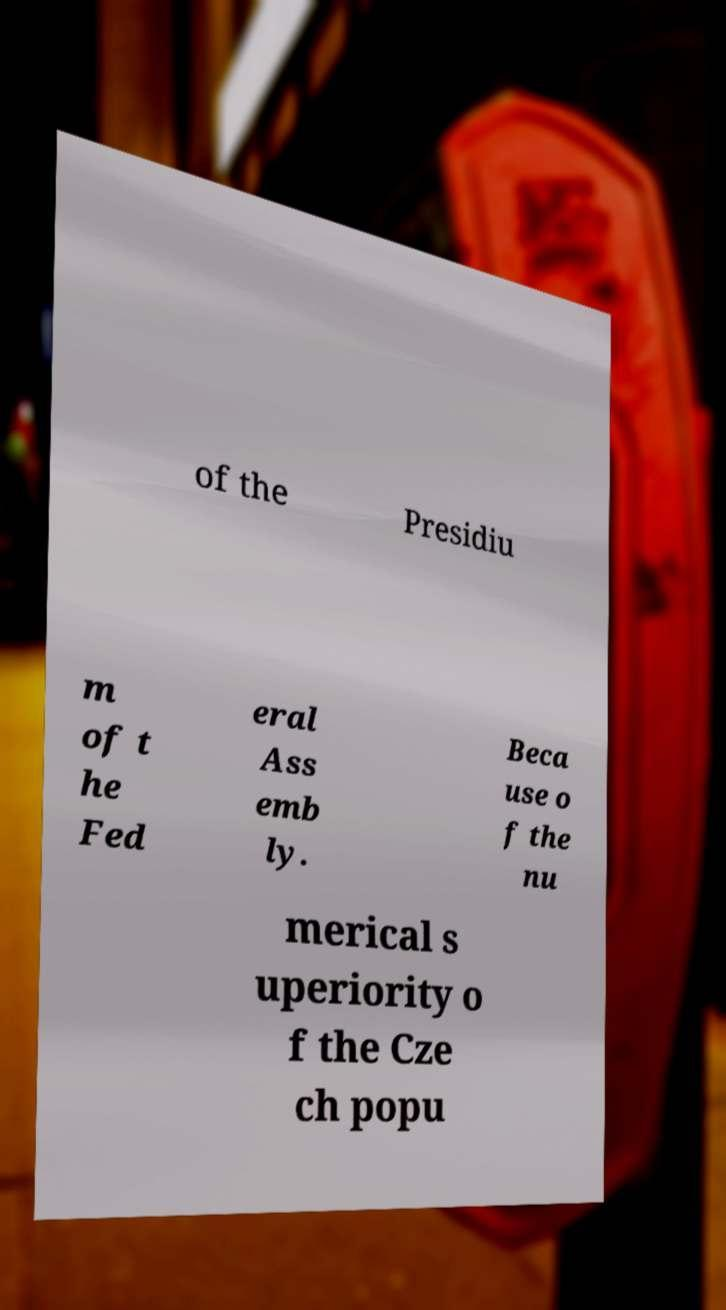Please identify and transcribe the text found in this image. of the Presidiu m of t he Fed eral Ass emb ly. Beca use o f the nu merical s uperiority o f the Cze ch popu 